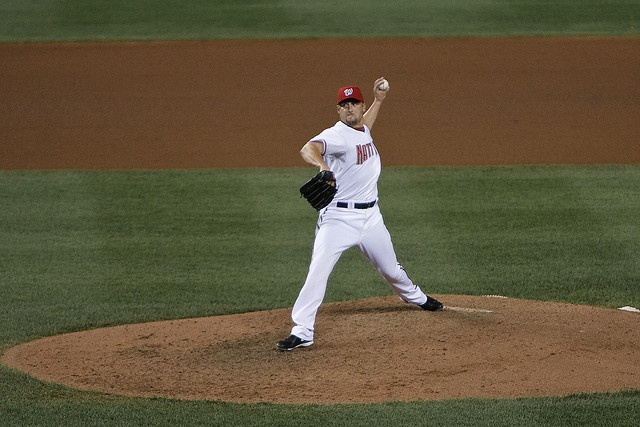Describe the objects in this image and their specific colors. I can see people in darkgreen, lavender, maroon, gray, and darkgray tones, baseball glove in darkgreen, black, and gray tones, and sports ball in darkgreen, lightgray, darkgray, gray, and maroon tones in this image. 